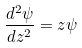Convert formula to latex. <formula><loc_0><loc_0><loc_500><loc_500>\frac { d ^ { 2 } \psi } { d z ^ { 2 } } = z \psi</formula> 